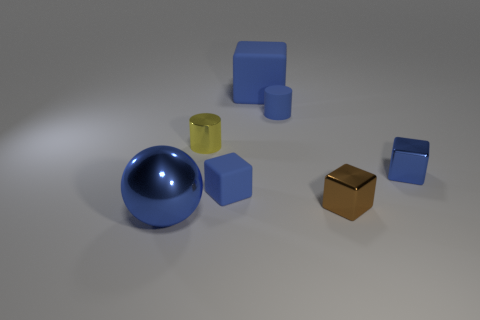Are there any blue blocks that have the same material as the tiny blue cylinder?
Offer a very short reply. Yes. How big is the blue sphere?
Provide a succinct answer. Large. What is the size of the blue metallic thing that is behind the tiny blue block that is on the left side of the large cube?
Provide a succinct answer. Small. What material is the large object that is the same shape as the tiny brown metallic thing?
Make the answer very short. Rubber. How many matte cubes are there?
Your answer should be compact. 2. There is a small block that is behind the blue matte thing that is left of the big matte thing to the left of the brown metallic object; what color is it?
Give a very brief answer. Blue. Are there fewer tiny shiny things than tiny blue metal blocks?
Offer a very short reply. No. What color is the small rubber thing that is the same shape as the big rubber object?
Offer a very short reply. Blue. What color is the small cylinder that is made of the same material as the small brown object?
Provide a succinct answer. Yellow. What number of blue metallic things are the same size as the blue ball?
Your answer should be compact. 0. 